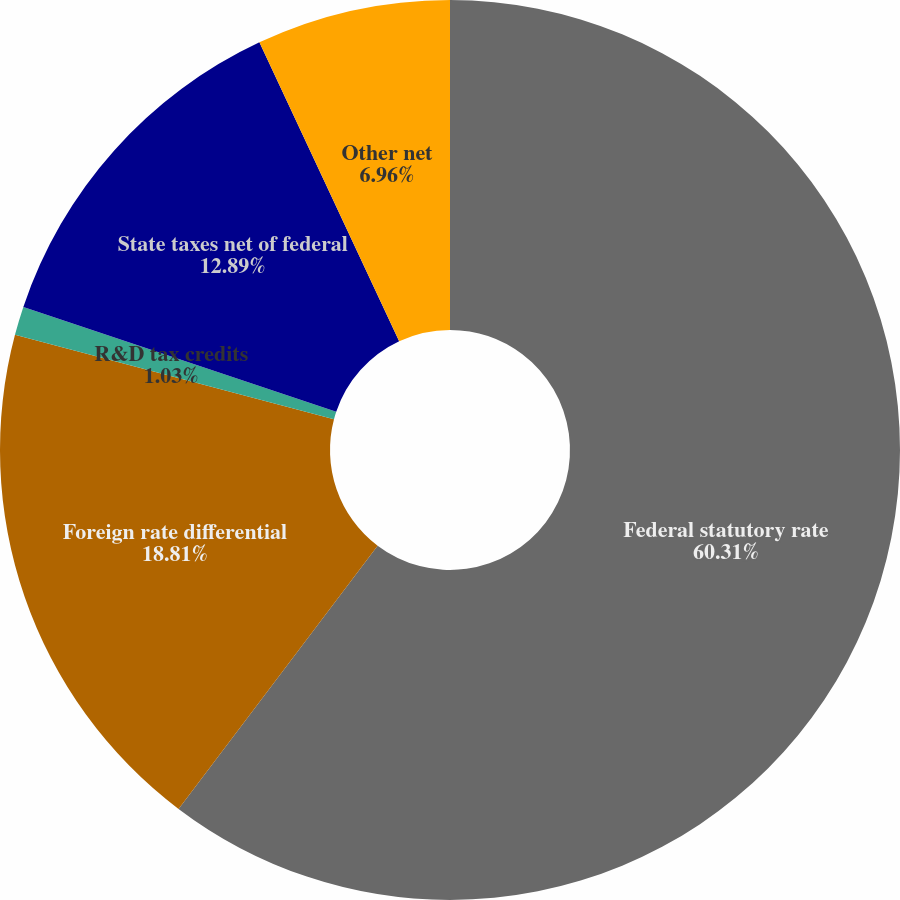<chart> <loc_0><loc_0><loc_500><loc_500><pie_chart><fcel>Federal statutory rate<fcel>Foreign rate differential<fcel>R&D tax credits<fcel>State taxes net of federal<fcel>Other net<nl><fcel>60.3%<fcel>18.81%<fcel>1.03%<fcel>12.89%<fcel>6.96%<nl></chart> 